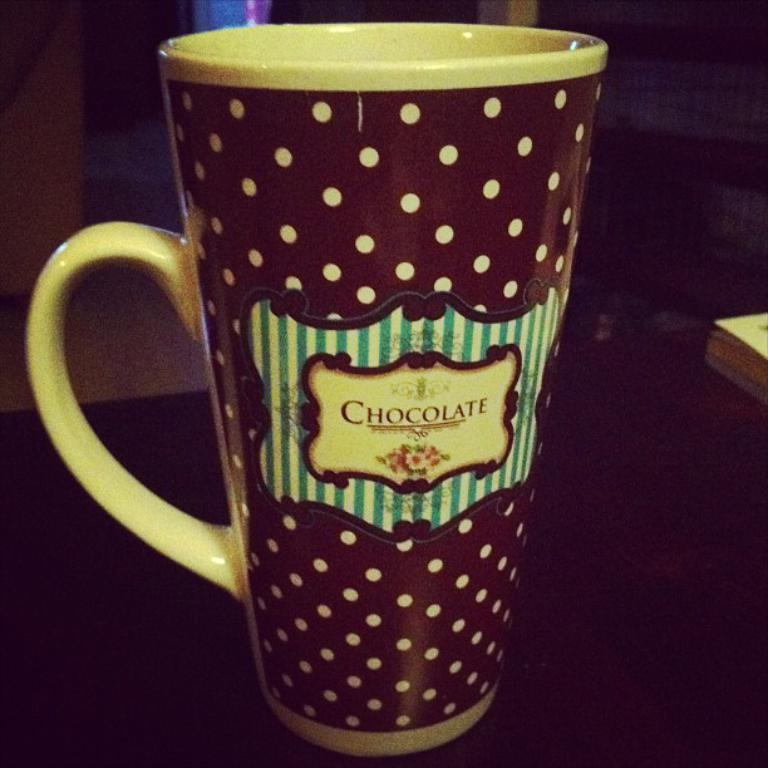<image>
Share a concise interpretation of the image provided. large coffee cup with the words choclate written acrross 